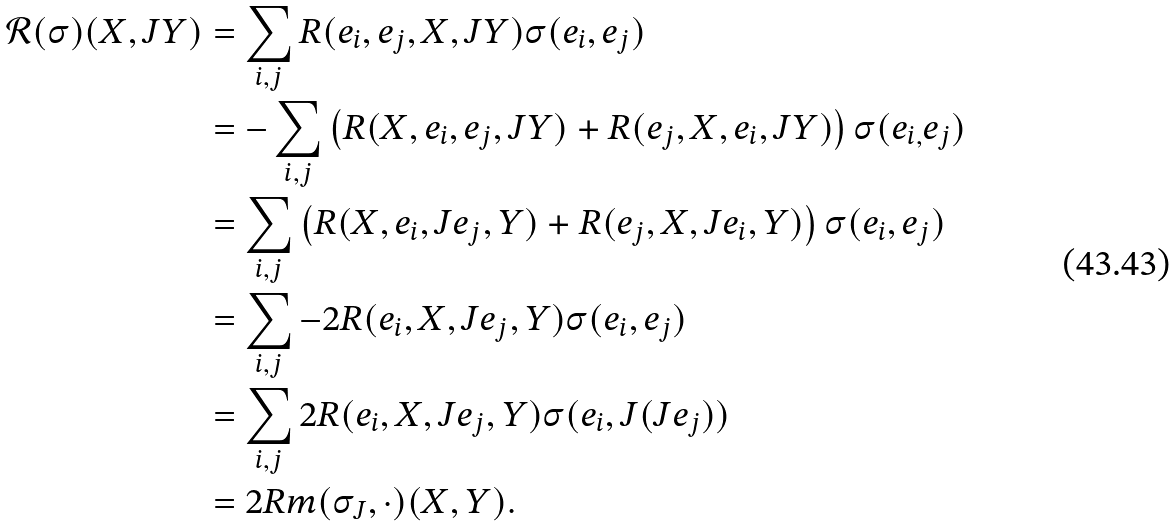Convert formula to latex. <formula><loc_0><loc_0><loc_500><loc_500>\mathcal { R } ( \sigma ) ( X , J Y ) & = \sum _ { i , j } R ( e _ { i } , e _ { j } , X , J Y ) \sigma ( e _ { i } , e _ { j } ) \\ & = - \sum _ { i , j } \left ( R ( X , e _ { i } , e _ { j } , J Y ) + R ( e _ { j } , X , e _ { i } , J Y ) \right ) \sigma ( e _ { i , } e _ { j } ) \\ & = \sum _ { i , j } \left ( R ( X , e _ { i } , J e _ { j } , Y ) + R ( e _ { j } , X , J e _ { i } , Y ) \right ) \sigma ( e _ { i } , e _ { j } ) \\ & = \sum _ { i , j } - 2 R ( e _ { i } , X , J e _ { j } , Y ) \sigma ( e _ { i } , e _ { j } ) \\ & = \sum _ { i , j } 2 R ( e _ { i } , X , J e _ { j } , Y ) \sigma ( e _ { i } , J ( J e _ { j } ) ) \\ & = 2 R m ( \sigma _ { J } , \cdot ) ( X , Y ) .</formula> 